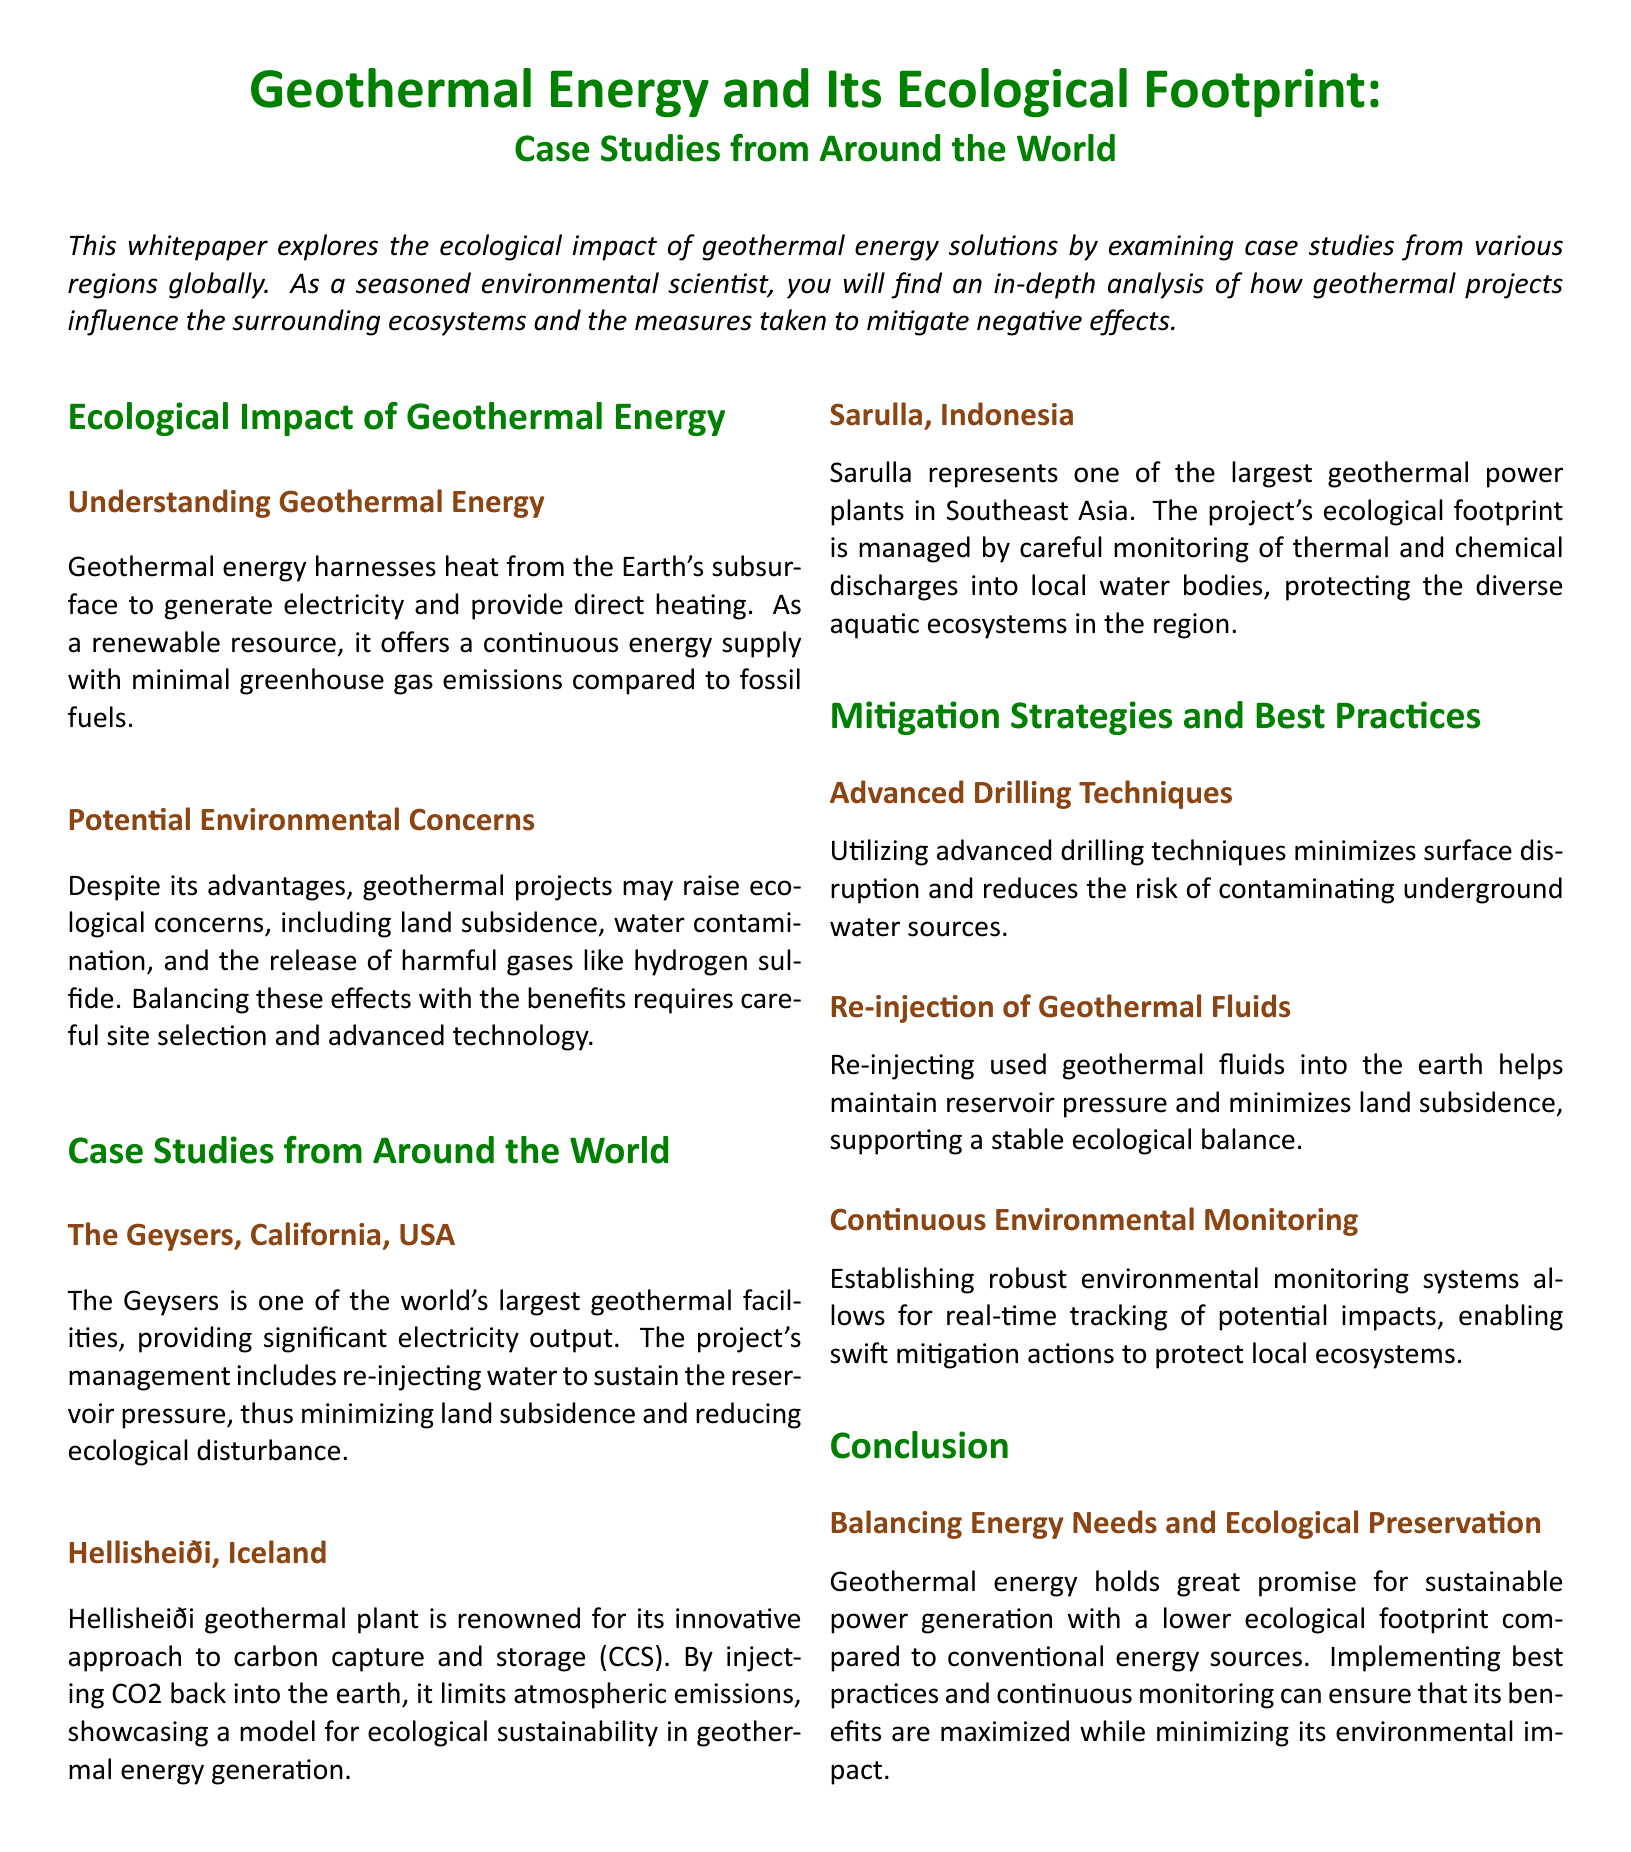what is the main focus of the whitepaper? The main focus is on the ecological impact of geothermal energy solutions through case studies from various regions globally.
Answer: ecological impact of geothermal energy solutions what is one potential environmental concern raised by geothermal projects? A potential environmental concern mentioned in the document is land subsidence.
Answer: land subsidence which geothermal facility is located in California, USA? The document identifies The Geysers as one of the world's largest geothermal facilities in California.
Answer: The Geysers what innovative approach is used by Hellisheiði geothermal plant? Hellisheiði is noted for its innovative approach to carbon capture and storage (CCS).
Answer: carbon capture and storage (CCS) how does the Sarulla project manage its ecological footprint? The Sarulla project manages its ecological footprint by monitoring thermal and chemical discharges into local water bodies.
Answer: careful monitoring what is a strategy mentioned for minimizing surface disruption? Advanced drilling techniques are mentioned as a strategy to minimize surface disruption.
Answer: advanced drilling techniques why is continuous environmental monitoring important according to the document? Continuous environmental monitoring is essential for real-time tracking of potential impacts to protect local ecosystems.
Answer: real-time tracking what type of energy resource is geothermal energy classified as? Geothermal energy is classified as a renewable resource.
Answer: renewable resource 